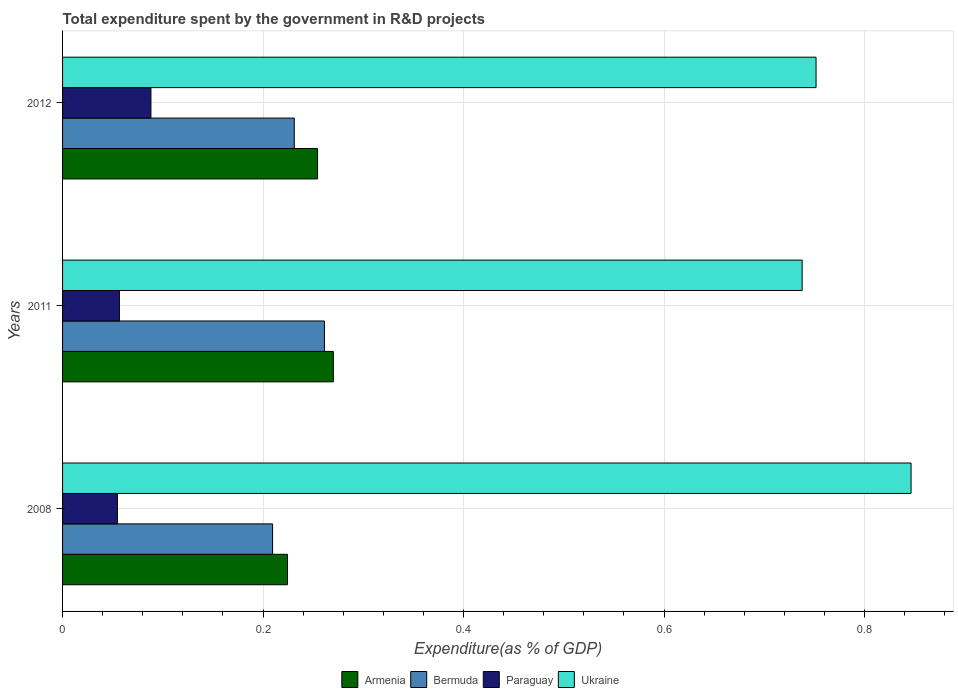How many different coloured bars are there?
Provide a succinct answer. 4. How many groups of bars are there?
Keep it short and to the point. 3. Are the number of bars per tick equal to the number of legend labels?
Offer a very short reply. Yes. How many bars are there on the 3rd tick from the top?
Ensure brevity in your answer.  4. What is the label of the 2nd group of bars from the top?
Offer a terse response. 2011. What is the total expenditure spent by the government in R&D projects in Armenia in 2011?
Your response must be concise. 0.27. Across all years, what is the maximum total expenditure spent by the government in R&D projects in Paraguay?
Provide a short and direct response. 0.09. Across all years, what is the minimum total expenditure spent by the government in R&D projects in Ukraine?
Your response must be concise. 0.74. In which year was the total expenditure spent by the government in R&D projects in Ukraine maximum?
Your response must be concise. 2008. In which year was the total expenditure spent by the government in R&D projects in Ukraine minimum?
Ensure brevity in your answer.  2011. What is the total total expenditure spent by the government in R&D projects in Armenia in the graph?
Ensure brevity in your answer.  0.75. What is the difference between the total expenditure spent by the government in R&D projects in Bermuda in 2008 and that in 2012?
Ensure brevity in your answer.  -0.02. What is the difference between the total expenditure spent by the government in R&D projects in Ukraine in 2011 and the total expenditure spent by the government in R&D projects in Armenia in 2008?
Keep it short and to the point. 0.51. What is the average total expenditure spent by the government in R&D projects in Bermuda per year?
Keep it short and to the point. 0.23. In the year 2008, what is the difference between the total expenditure spent by the government in R&D projects in Armenia and total expenditure spent by the government in R&D projects in Bermuda?
Make the answer very short. 0.01. In how many years, is the total expenditure spent by the government in R&D projects in Ukraine greater than 0.6000000000000001 %?
Provide a short and direct response. 3. What is the ratio of the total expenditure spent by the government in R&D projects in Armenia in 2008 to that in 2012?
Provide a short and direct response. 0.88. Is the total expenditure spent by the government in R&D projects in Ukraine in 2011 less than that in 2012?
Your answer should be compact. Yes. What is the difference between the highest and the second highest total expenditure spent by the government in R&D projects in Bermuda?
Give a very brief answer. 0.03. What is the difference between the highest and the lowest total expenditure spent by the government in R&D projects in Armenia?
Offer a very short reply. 0.05. Is the sum of the total expenditure spent by the government in R&D projects in Ukraine in 2008 and 2012 greater than the maximum total expenditure spent by the government in R&D projects in Paraguay across all years?
Your answer should be very brief. Yes. What does the 3rd bar from the top in 2008 represents?
Give a very brief answer. Bermuda. What does the 4th bar from the bottom in 2011 represents?
Make the answer very short. Ukraine. How many bars are there?
Your answer should be very brief. 12. Are all the bars in the graph horizontal?
Ensure brevity in your answer.  Yes. What is the difference between two consecutive major ticks on the X-axis?
Provide a succinct answer. 0.2. Are the values on the major ticks of X-axis written in scientific E-notation?
Make the answer very short. No. Does the graph contain any zero values?
Your answer should be compact. No. Does the graph contain grids?
Your answer should be very brief. Yes. Where does the legend appear in the graph?
Your response must be concise. Bottom center. How many legend labels are there?
Offer a very short reply. 4. What is the title of the graph?
Your answer should be compact. Total expenditure spent by the government in R&D projects. Does "Comoros" appear as one of the legend labels in the graph?
Provide a short and direct response. No. What is the label or title of the X-axis?
Offer a very short reply. Expenditure(as % of GDP). What is the Expenditure(as % of GDP) of Armenia in 2008?
Offer a very short reply. 0.22. What is the Expenditure(as % of GDP) in Bermuda in 2008?
Ensure brevity in your answer.  0.21. What is the Expenditure(as % of GDP) of Paraguay in 2008?
Give a very brief answer. 0.05. What is the Expenditure(as % of GDP) in Ukraine in 2008?
Keep it short and to the point. 0.85. What is the Expenditure(as % of GDP) in Armenia in 2011?
Your response must be concise. 0.27. What is the Expenditure(as % of GDP) in Bermuda in 2011?
Provide a succinct answer. 0.26. What is the Expenditure(as % of GDP) of Paraguay in 2011?
Ensure brevity in your answer.  0.06. What is the Expenditure(as % of GDP) in Ukraine in 2011?
Provide a short and direct response. 0.74. What is the Expenditure(as % of GDP) in Armenia in 2012?
Your answer should be very brief. 0.25. What is the Expenditure(as % of GDP) in Bermuda in 2012?
Your answer should be very brief. 0.23. What is the Expenditure(as % of GDP) of Paraguay in 2012?
Your answer should be very brief. 0.09. What is the Expenditure(as % of GDP) of Ukraine in 2012?
Your answer should be compact. 0.75. Across all years, what is the maximum Expenditure(as % of GDP) in Armenia?
Your answer should be compact. 0.27. Across all years, what is the maximum Expenditure(as % of GDP) of Bermuda?
Provide a succinct answer. 0.26. Across all years, what is the maximum Expenditure(as % of GDP) of Paraguay?
Offer a very short reply. 0.09. Across all years, what is the maximum Expenditure(as % of GDP) in Ukraine?
Your answer should be compact. 0.85. Across all years, what is the minimum Expenditure(as % of GDP) in Armenia?
Give a very brief answer. 0.22. Across all years, what is the minimum Expenditure(as % of GDP) of Bermuda?
Ensure brevity in your answer.  0.21. Across all years, what is the minimum Expenditure(as % of GDP) of Paraguay?
Your response must be concise. 0.05. Across all years, what is the minimum Expenditure(as % of GDP) in Ukraine?
Keep it short and to the point. 0.74. What is the total Expenditure(as % of GDP) in Armenia in the graph?
Provide a short and direct response. 0.75. What is the total Expenditure(as % of GDP) of Bermuda in the graph?
Your answer should be compact. 0.7. What is the total Expenditure(as % of GDP) of Paraguay in the graph?
Your response must be concise. 0.2. What is the total Expenditure(as % of GDP) in Ukraine in the graph?
Offer a very short reply. 2.34. What is the difference between the Expenditure(as % of GDP) in Armenia in 2008 and that in 2011?
Make the answer very short. -0.05. What is the difference between the Expenditure(as % of GDP) of Bermuda in 2008 and that in 2011?
Provide a succinct answer. -0.05. What is the difference between the Expenditure(as % of GDP) of Paraguay in 2008 and that in 2011?
Your answer should be compact. -0. What is the difference between the Expenditure(as % of GDP) of Ukraine in 2008 and that in 2011?
Ensure brevity in your answer.  0.11. What is the difference between the Expenditure(as % of GDP) in Armenia in 2008 and that in 2012?
Your answer should be very brief. -0.03. What is the difference between the Expenditure(as % of GDP) in Bermuda in 2008 and that in 2012?
Your answer should be very brief. -0.02. What is the difference between the Expenditure(as % of GDP) of Paraguay in 2008 and that in 2012?
Provide a short and direct response. -0.03. What is the difference between the Expenditure(as % of GDP) of Ukraine in 2008 and that in 2012?
Make the answer very short. 0.09. What is the difference between the Expenditure(as % of GDP) of Armenia in 2011 and that in 2012?
Provide a short and direct response. 0.02. What is the difference between the Expenditure(as % of GDP) in Bermuda in 2011 and that in 2012?
Ensure brevity in your answer.  0.03. What is the difference between the Expenditure(as % of GDP) of Paraguay in 2011 and that in 2012?
Your response must be concise. -0.03. What is the difference between the Expenditure(as % of GDP) in Ukraine in 2011 and that in 2012?
Provide a short and direct response. -0.01. What is the difference between the Expenditure(as % of GDP) of Armenia in 2008 and the Expenditure(as % of GDP) of Bermuda in 2011?
Offer a very short reply. -0.04. What is the difference between the Expenditure(as % of GDP) of Armenia in 2008 and the Expenditure(as % of GDP) of Paraguay in 2011?
Offer a very short reply. 0.17. What is the difference between the Expenditure(as % of GDP) of Armenia in 2008 and the Expenditure(as % of GDP) of Ukraine in 2011?
Ensure brevity in your answer.  -0.51. What is the difference between the Expenditure(as % of GDP) of Bermuda in 2008 and the Expenditure(as % of GDP) of Paraguay in 2011?
Make the answer very short. 0.15. What is the difference between the Expenditure(as % of GDP) of Bermuda in 2008 and the Expenditure(as % of GDP) of Ukraine in 2011?
Make the answer very short. -0.53. What is the difference between the Expenditure(as % of GDP) in Paraguay in 2008 and the Expenditure(as % of GDP) in Ukraine in 2011?
Your answer should be very brief. -0.68. What is the difference between the Expenditure(as % of GDP) of Armenia in 2008 and the Expenditure(as % of GDP) of Bermuda in 2012?
Your answer should be very brief. -0.01. What is the difference between the Expenditure(as % of GDP) in Armenia in 2008 and the Expenditure(as % of GDP) in Paraguay in 2012?
Make the answer very short. 0.14. What is the difference between the Expenditure(as % of GDP) in Armenia in 2008 and the Expenditure(as % of GDP) in Ukraine in 2012?
Your answer should be compact. -0.53. What is the difference between the Expenditure(as % of GDP) of Bermuda in 2008 and the Expenditure(as % of GDP) of Paraguay in 2012?
Provide a succinct answer. 0.12. What is the difference between the Expenditure(as % of GDP) of Bermuda in 2008 and the Expenditure(as % of GDP) of Ukraine in 2012?
Keep it short and to the point. -0.54. What is the difference between the Expenditure(as % of GDP) in Paraguay in 2008 and the Expenditure(as % of GDP) in Ukraine in 2012?
Provide a succinct answer. -0.7. What is the difference between the Expenditure(as % of GDP) in Armenia in 2011 and the Expenditure(as % of GDP) in Bermuda in 2012?
Ensure brevity in your answer.  0.04. What is the difference between the Expenditure(as % of GDP) of Armenia in 2011 and the Expenditure(as % of GDP) of Paraguay in 2012?
Make the answer very short. 0.18. What is the difference between the Expenditure(as % of GDP) in Armenia in 2011 and the Expenditure(as % of GDP) in Ukraine in 2012?
Ensure brevity in your answer.  -0.48. What is the difference between the Expenditure(as % of GDP) of Bermuda in 2011 and the Expenditure(as % of GDP) of Paraguay in 2012?
Ensure brevity in your answer.  0.17. What is the difference between the Expenditure(as % of GDP) of Bermuda in 2011 and the Expenditure(as % of GDP) of Ukraine in 2012?
Ensure brevity in your answer.  -0.49. What is the difference between the Expenditure(as % of GDP) of Paraguay in 2011 and the Expenditure(as % of GDP) of Ukraine in 2012?
Provide a succinct answer. -0.69. What is the average Expenditure(as % of GDP) in Armenia per year?
Provide a short and direct response. 0.25. What is the average Expenditure(as % of GDP) of Bermuda per year?
Provide a succinct answer. 0.23. What is the average Expenditure(as % of GDP) of Paraguay per year?
Your response must be concise. 0.07. What is the average Expenditure(as % of GDP) of Ukraine per year?
Offer a terse response. 0.78. In the year 2008, what is the difference between the Expenditure(as % of GDP) in Armenia and Expenditure(as % of GDP) in Bermuda?
Offer a terse response. 0.01. In the year 2008, what is the difference between the Expenditure(as % of GDP) of Armenia and Expenditure(as % of GDP) of Paraguay?
Provide a short and direct response. 0.17. In the year 2008, what is the difference between the Expenditure(as % of GDP) in Armenia and Expenditure(as % of GDP) in Ukraine?
Provide a succinct answer. -0.62. In the year 2008, what is the difference between the Expenditure(as % of GDP) of Bermuda and Expenditure(as % of GDP) of Paraguay?
Offer a very short reply. 0.15. In the year 2008, what is the difference between the Expenditure(as % of GDP) in Bermuda and Expenditure(as % of GDP) in Ukraine?
Give a very brief answer. -0.64. In the year 2008, what is the difference between the Expenditure(as % of GDP) in Paraguay and Expenditure(as % of GDP) in Ukraine?
Give a very brief answer. -0.79. In the year 2011, what is the difference between the Expenditure(as % of GDP) in Armenia and Expenditure(as % of GDP) in Bermuda?
Offer a very short reply. 0.01. In the year 2011, what is the difference between the Expenditure(as % of GDP) in Armenia and Expenditure(as % of GDP) in Paraguay?
Your answer should be very brief. 0.21. In the year 2011, what is the difference between the Expenditure(as % of GDP) in Armenia and Expenditure(as % of GDP) in Ukraine?
Your answer should be very brief. -0.47. In the year 2011, what is the difference between the Expenditure(as % of GDP) of Bermuda and Expenditure(as % of GDP) of Paraguay?
Keep it short and to the point. 0.2. In the year 2011, what is the difference between the Expenditure(as % of GDP) in Bermuda and Expenditure(as % of GDP) in Ukraine?
Make the answer very short. -0.48. In the year 2011, what is the difference between the Expenditure(as % of GDP) of Paraguay and Expenditure(as % of GDP) of Ukraine?
Ensure brevity in your answer.  -0.68. In the year 2012, what is the difference between the Expenditure(as % of GDP) in Armenia and Expenditure(as % of GDP) in Bermuda?
Give a very brief answer. 0.02. In the year 2012, what is the difference between the Expenditure(as % of GDP) in Armenia and Expenditure(as % of GDP) in Paraguay?
Your response must be concise. 0.17. In the year 2012, what is the difference between the Expenditure(as % of GDP) in Armenia and Expenditure(as % of GDP) in Ukraine?
Offer a terse response. -0.5. In the year 2012, what is the difference between the Expenditure(as % of GDP) in Bermuda and Expenditure(as % of GDP) in Paraguay?
Keep it short and to the point. 0.14. In the year 2012, what is the difference between the Expenditure(as % of GDP) of Bermuda and Expenditure(as % of GDP) of Ukraine?
Provide a short and direct response. -0.52. In the year 2012, what is the difference between the Expenditure(as % of GDP) in Paraguay and Expenditure(as % of GDP) in Ukraine?
Offer a very short reply. -0.66. What is the ratio of the Expenditure(as % of GDP) in Armenia in 2008 to that in 2011?
Your response must be concise. 0.83. What is the ratio of the Expenditure(as % of GDP) in Bermuda in 2008 to that in 2011?
Make the answer very short. 0.8. What is the ratio of the Expenditure(as % of GDP) of Paraguay in 2008 to that in 2011?
Make the answer very short. 0.96. What is the ratio of the Expenditure(as % of GDP) in Ukraine in 2008 to that in 2011?
Ensure brevity in your answer.  1.15. What is the ratio of the Expenditure(as % of GDP) of Armenia in 2008 to that in 2012?
Offer a very short reply. 0.88. What is the ratio of the Expenditure(as % of GDP) in Bermuda in 2008 to that in 2012?
Provide a succinct answer. 0.91. What is the ratio of the Expenditure(as % of GDP) of Paraguay in 2008 to that in 2012?
Offer a very short reply. 0.62. What is the ratio of the Expenditure(as % of GDP) of Ukraine in 2008 to that in 2012?
Your answer should be very brief. 1.13. What is the ratio of the Expenditure(as % of GDP) of Armenia in 2011 to that in 2012?
Give a very brief answer. 1.06. What is the ratio of the Expenditure(as % of GDP) in Bermuda in 2011 to that in 2012?
Offer a very short reply. 1.13. What is the ratio of the Expenditure(as % of GDP) of Paraguay in 2011 to that in 2012?
Provide a short and direct response. 0.64. What is the ratio of the Expenditure(as % of GDP) of Ukraine in 2011 to that in 2012?
Keep it short and to the point. 0.98. What is the difference between the highest and the second highest Expenditure(as % of GDP) of Armenia?
Make the answer very short. 0.02. What is the difference between the highest and the second highest Expenditure(as % of GDP) of Bermuda?
Give a very brief answer. 0.03. What is the difference between the highest and the second highest Expenditure(as % of GDP) of Paraguay?
Keep it short and to the point. 0.03. What is the difference between the highest and the second highest Expenditure(as % of GDP) in Ukraine?
Offer a terse response. 0.09. What is the difference between the highest and the lowest Expenditure(as % of GDP) of Armenia?
Offer a terse response. 0.05. What is the difference between the highest and the lowest Expenditure(as % of GDP) of Bermuda?
Ensure brevity in your answer.  0.05. What is the difference between the highest and the lowest Expenditure(as % of GDP) of Paraguay?
Keep it short and to the point. 0.03. What is the difference between the highest and the lowest Expenditure(as % of GDP) in Ukraine?
Give a very brief answer. 0.11. 